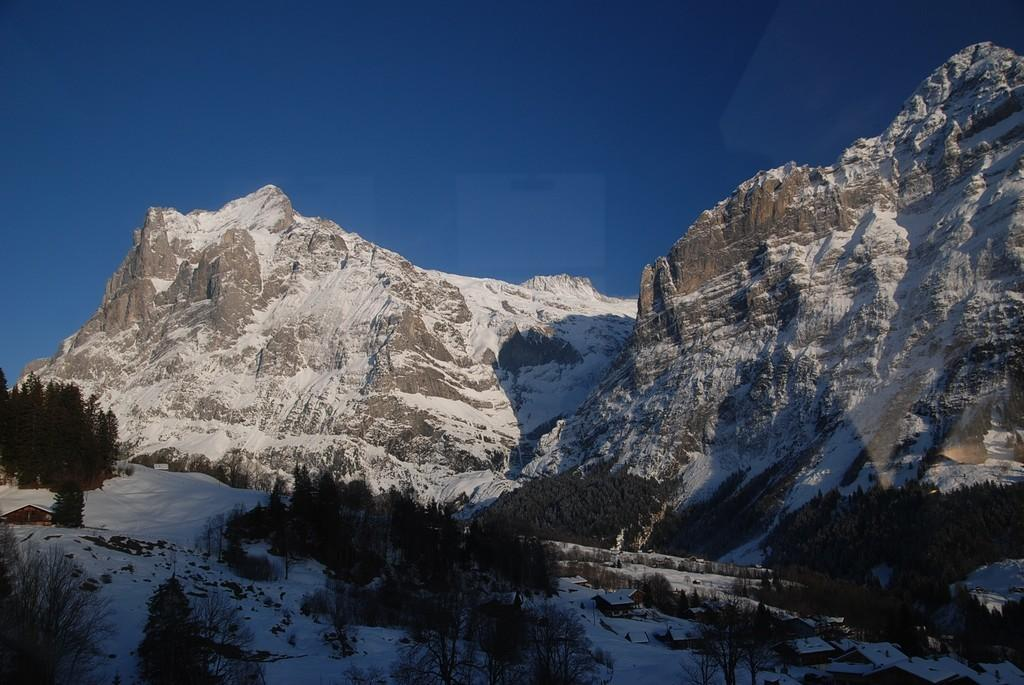What type of natural feature is present in the image? There are mountains with snow in the image. What other natural elements can be seen in the image? There are trees in the image. What is visible in the background of the image? The sky is visible in the image. How would you describe the sky in the image? The sky appears cloudy in the image. How many girls are holding gold bars in the image? There are no girls or gold bars present in the image. 